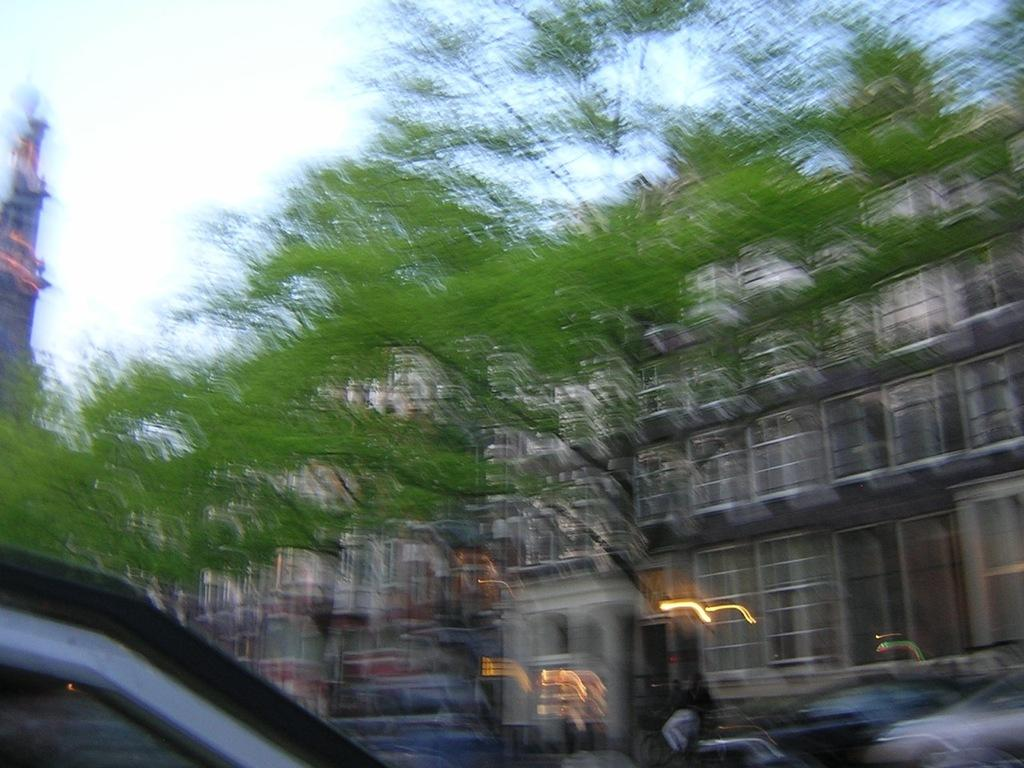What types of objects can be seen in the image? There are vehicles, trees, and buildings with windows in the image. Can you describe the buildings in the image? The buildings have windows. What is visible in the background of the image? The sky is visible in the background of the image. How would you describe the overall quality of the image? The image is blurry. What type of brain is visible in the image? There is no brain present in the image. Is there a skirt visible in the image? There is no skirt present in the image. 